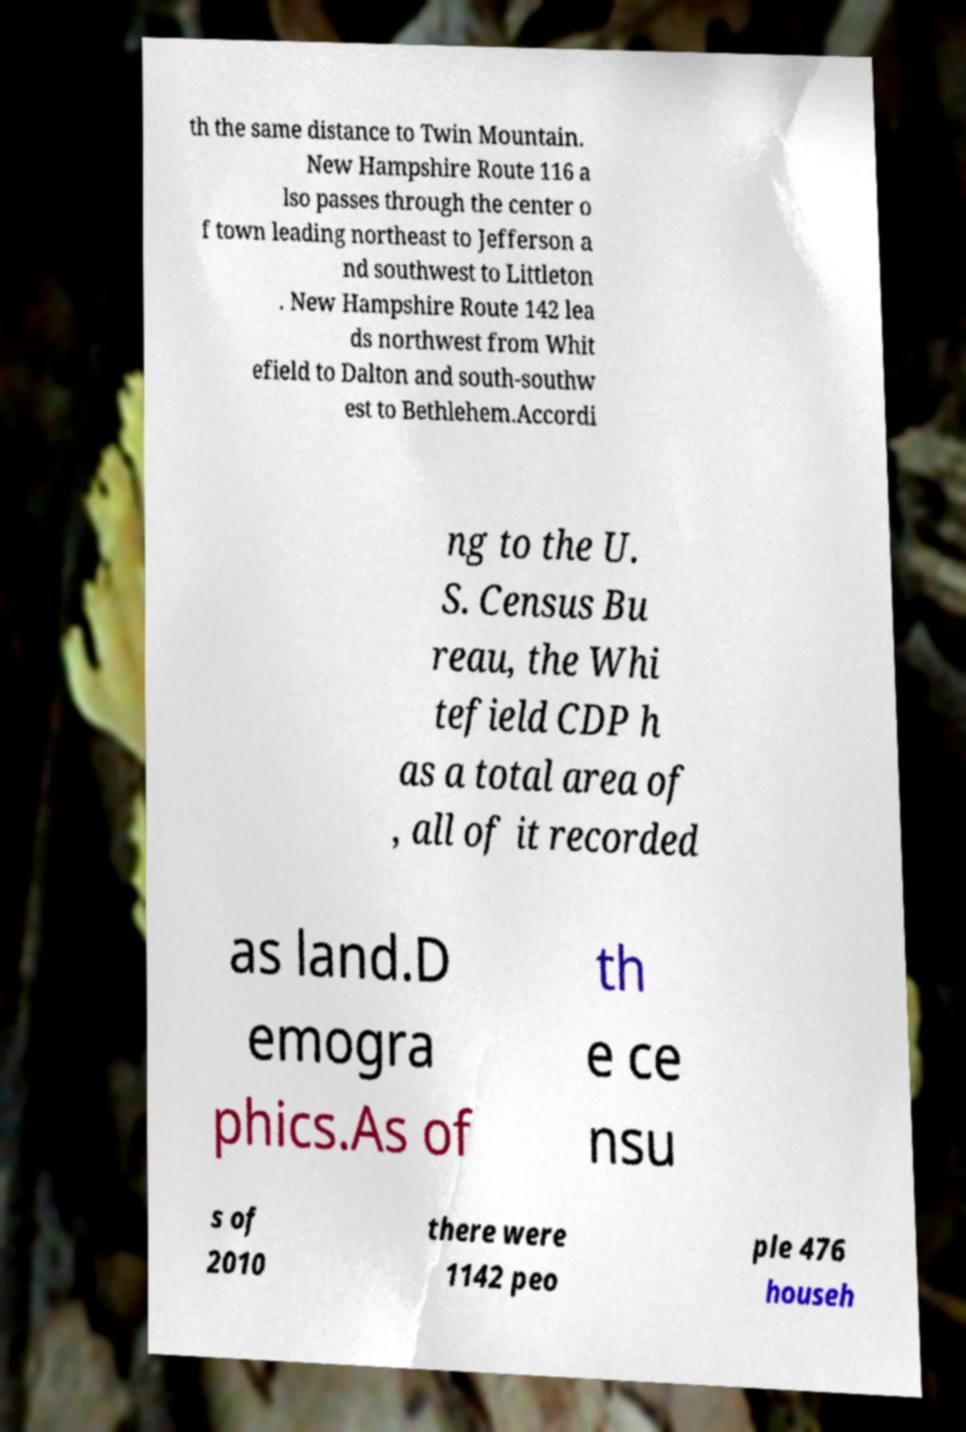For documentation purposes, I need the text within this image transcribed. Could you provide that? th the same distance to Twin Mountain. New Hampshire Route 116 a lso passes through the center o f town leading northeast to Jefferson a nd southwest to Littleton . New Hampshire Route 142 lea ds northwest from Whit efield to Dalton and south-southw est to Bethlehem.Accordi ng to the U. S. Census Bu reau, the Whi tefield CDP h as a total area of , all of it recorded as land.D emogra phics.As of th e ce nsu s of 2010 there were 1142 peo ple 476 househ 